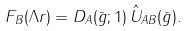<formula> <loc_0><loc_0><loc_500><loc_500>F _ { B } ( \Lambda r ) = D _ { A } ( \bar { g } ; 1 ) \, \hat { U } _ { A B } ( \bar { g } ) .</formula> 